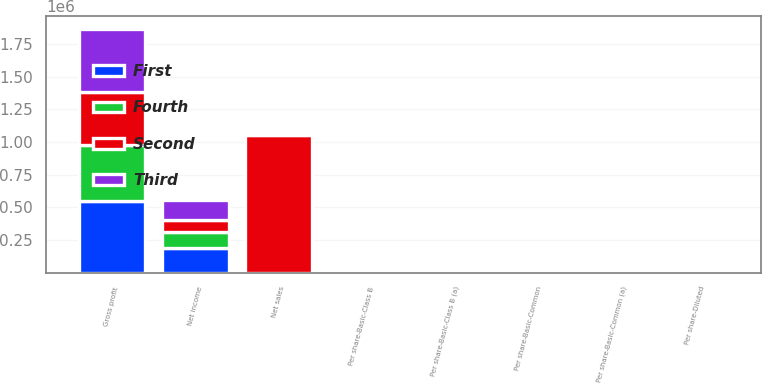Convert chart. <chart><loc_0><loc_0><loc_500><loc_500><stacked_bar_chart><ecel><fcel>Net sales<fcel>Gross profit<fcel>Net income<fcel>Per share-Basic-Common (a)<fcel>Per share-Basic-Class B<fcel>Per share-Diluted<fcel>Per share-Basic-Common<fcel>Per share-Basic-Class B (a)<nl><fcel>Fourth<fcel>0.65<fcel>432142<fcel>122471<fcel>0.52<fcel>0.47<fcel>0.5<fcel>0.48<fcel>0.44<nl><fcel>Second<fcel>1.05191e+06<fcel>407835<fcel>97897<fcel>0.42<fcel>0.38<fcel>0.41<fcel>0.39<fcel>0.36<nl><fcel>First<fcel>0.65<fcel>545469<fcel>185121<fcel>0.81<fcel>0.73<fcel>0.78<fcel>0.46<fcel>0.41<nl><fcel>Third<fcel>0.65<fcel>482066<fcel>153572<fcel>0.68<fcel>0.61<fcel>0.65<fcel>0.72<fcel>0.65<nl></chart> 